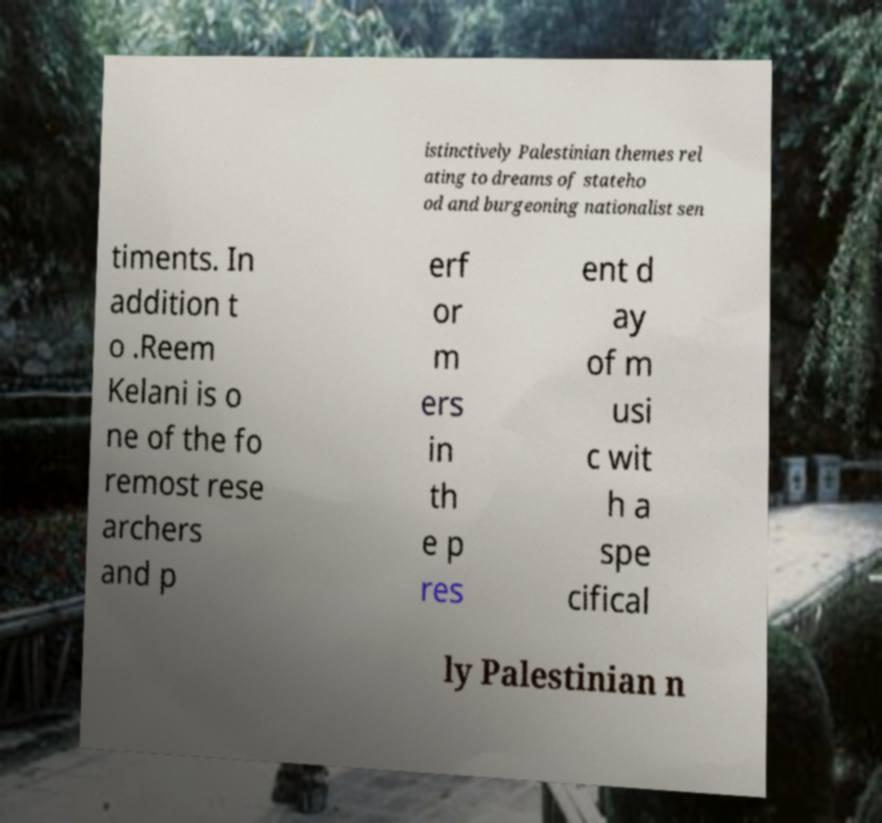I need the written content from this picture converted into text. Can you do that? istinctively Palestinian themes rel ating to dreams of stateho od and burgeoning nationalist sen timents. In addition t o .Reem Kelani is o ne of the fo remost rese archers and p erf or m ers in th e p res ent d ay of m usi c wit h a spe cifical ly Palestinian n 